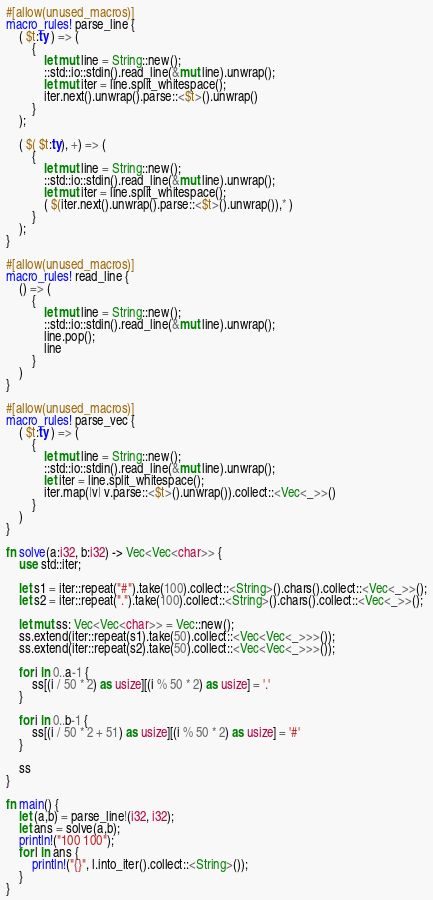Convert code to text. <code><loc_0><loc_0><loc_500><loc_500><_Rust_>#[allow(unused_macros)]
macro_rules! parse_line {
    ( $t:ty ) => (
        {
            let mut line = String::new();
            ::std::io::stdin().read_line(&mut line).unwrap();
            let mut iter = line.split_whitespace();
            iter.next().unwrap().parse::<$t>().unwrap()
        }
    );

    ( $( $t:ty), +) => (
        {
            let mut line = String::new();
            ::std::io::stdin().read_line(&mut line).unwrap();
            let mut iter = line.split_whitespace();
            ( $(iter.next().unwrap().parse::<$t>().unwrap()),* )
        }
    );
}

#[allow(unused_macros)]
macro_rules! read_line {
    () => (
        {
            let mut line = String::new();
            ::std::io::stdin().read_line(&mut line).unwrap();
            line.pop();
            line
        }
    )
}

#[allow(unused_macros)]
macro_rules! parse_vec {
    ( $t:ty ) => (
        {
            let mut line = String::new();
            ::std::io::stdin().read_line(&mut line).unwrap();
            let iter = line.split_whitespace();
            iter.map(|v| v.parse::<$t>().unwrap()).collect::<Vec<_>>()
        }
    )
}

fn solve(a:i32, b:i32) -> Vec<Vec<char>> {
    use std::iter;

    let s1 = iter::repeat("#").take(100).collect::<String>().chars().collect::<Vec<_>>();
    let s2 = iter::repeat(".").take(100).collect::<String>().chars().collect::<Vec<_>>();

    let mut ss: Vec<Vec<char>> = Vec::new();
    ss.extend(iter::repeat(s1).take(50).collect::<Vec<Vec<_>>>());
    ss.extend(iter::repeat(s2).take(50).collect::<Vec<Vec<_>>>());

    for i in 0..a-1 {
        ss[(i / 50 * 2) as usize][(i % 50 * 2) as usize] = '.'
    }

    for i in 0..b-1 {
        ss[(i / 50 * 2 + 51) as usize][(i % 50 * 2) as usize] = '#'
    }

    ss
}

fn main() {
    let (a,b) = parse_line!(i32, i32);
    let ans = solve(a,b);
    println!("100 100");
    for l in ans {
        println!("{}", l.into_iter().collect::<String>());
    }
}
</code> 